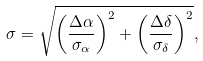<formula> <loc_0><loc_0><loc_500><loc_500>\sigma = \sqrt { \left ( \frac { \Delta \alpha } { \sigma _ { \alpha } } \right ) ^ { 2 } + \left ( \frac { \Delta \delta } { \sigma _ { \delta } } \right ) ^ { 2 } } ,</formula> 